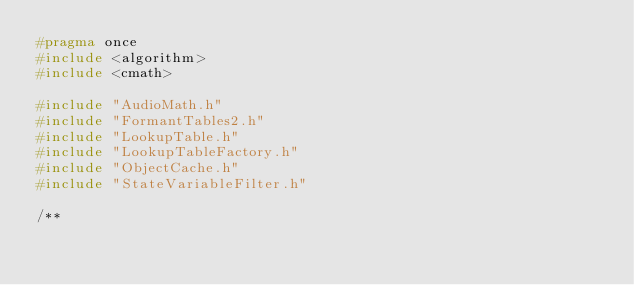Convert code to text. <code><loc_0><loc_0><loc_500><loc_500><_C_>#pragma once
#include <algorithm>
#include <cmath>

#include "AudioMath.h"
#include "FormantTables2.h"
#include "LookupTable.h"
#include "LookupTableFactory.h"
#include "ObjectCache.h"
#include "StateVariableFilter.h"

/**</code> 